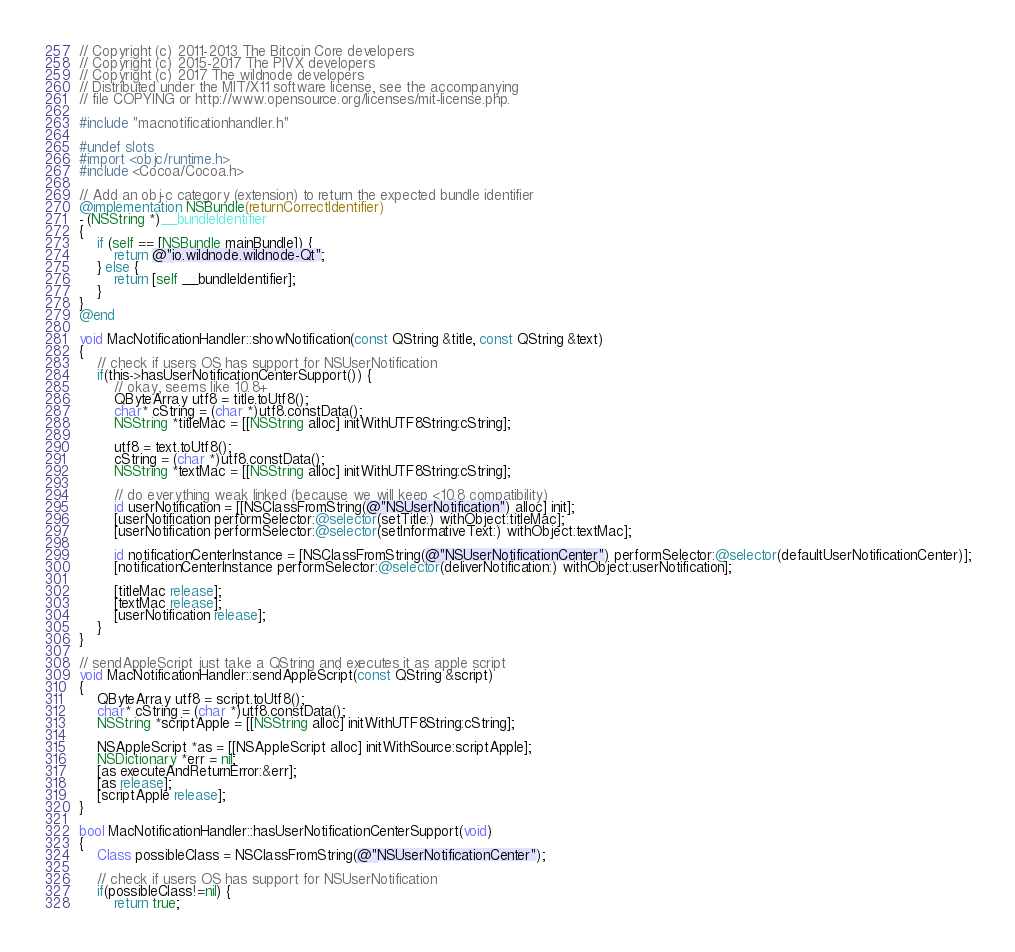Convert code to text. <code><loc_0><loc_0><loc_500><loc_500><_ObjectiveC_>// Copyright (c) 2011-2013 The Bitcoin Core developers
// Copyright (c) 2015-2017 The PIVX developers
// Copyright (c) 2017 The wildnode developers
// Distributed under the MIT/X11 software license, see the accompanying
// file COPYING or http://www.opensource.org/licenses/mit-license.php.

#include "macnotificationhandler.h"

#undef slots
#import <objc/runtime.h>
#include <Cocoa/Cocoa.h>

// Add an obj-c category (extension) to return the expected bundle identifier
@implementation NSBundle(returnCorrectIdentifier)
- (NSString *)__bundleIdentifier
{
    if (self == [NSBundle mainBundle]) {
        return @"io.wildnode.wildnode-Qt";
    } else {
        return [self __bundleIdentifier];
    }
}
@end

void MacNotificationHandler::showNotification(const QString &title, const QString &text)
{
    // check if users OS has support for NSUserNotification
    if(this->hasUserNotificationCenterSupport()) {
        // okay, seems like 10.8+
        QByteArray utf8 = title.toUtf8();
        char* cString = (char *)utf8.constData();
        NSString *titleMac = [[NSString alloc] initWithUTF8String:cString];

        utf8 = text.toUtf8();
        cString = (char *)utf8.constData();
        NSString *textMac = [[NSString alloc] initWithUTF8String:cString];

        // do everything weak linked (because we will keep <10.8 compatibility)
        id userNotification = [[NSClassFromString(@"NSUserNotification") alloc] init];
        [userNotification performSelector:@selector(setTitle:) withObject:titleMac];
        [userNotification performSelector:@selector(setInformativeText:) withObject:textMac];

        id notificationCenterInstance = [NSClassFromString(@"NSUserNotificationCenter") performSelector:@selector(defaultUserNotificationCenter)];
        [notificationCenterInstance performSelector:@selector(deliverNotification:) withObject:userNotification];

        [titleMac release];
        [textMac release];
        [userNotification release];
    }
}

// sendAppleScript just take a QString and executes it as apple script
void MacNotificationHandler::sendAppleScript(const QString &script)
{
    QByteArray utf8 = script.toUtf8();
    char* cString = (char *)utf8.constData();
    NSString *scriptApple = [[NSString alloc] initWithUTF8String:cString];

    NSAppleScript *as = [[NSAppleScript alloc] initWithSource:scriptApple];
    NSDictionary *err = nil;
    [as executeAndReturnError:&err];
    [as release];
    [scriptApple release];
}

bool MacNotificationHandler::hasUserNotificationCenterSupport(void)
{
    Class possibleClass = NSClassFromString(@"NSUserNotificationCenter");

    // check if users OS has support for NSUserNotification
    if(possibleClass!=nil) {
        return true;</code> 